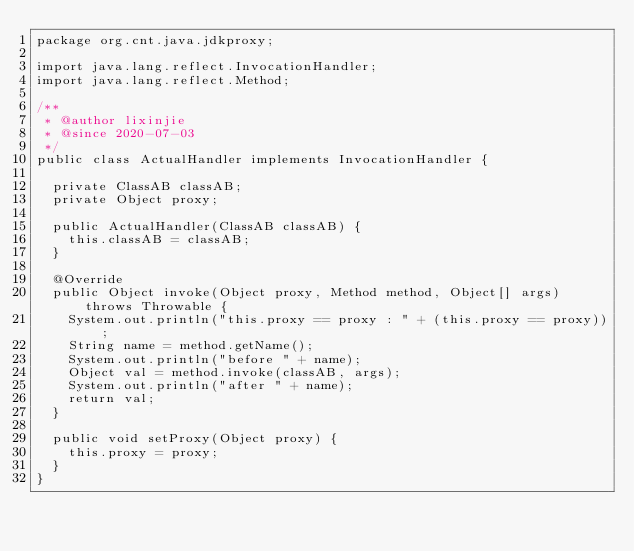<code> <loc_0><loc_0><loc_500><loc_500><_Java_>package org.cnt.java.jdkproxy;

import java.lang.reflect.InvocationHandler;
import java.lang.reflect.Method;

/**
 * @author lixinjie
 * @since 2020-07-03
 */
public class ActualHandler implements InvocationHandler {

	private ClassAB classAB;
	private Object proxy;
	
	public ActualHandler(ClassAB classAB) {
		this.classAB = classAB;
	}
	
	@Override
	public Object invoke(Object proxy, Method method, Object[] args) throws Throwable {
		System.out.println("this.proxy == proxy : " + (this.proxy == proxy));
		String name = method.getName();
		System.out.println("before " + name);
		Object val = method.invoke(classAB, args);
		System.out.println("after " + name);
		return val;
	}

	public void setProxy(Object proxy) {
		this.proxy = proxy;
	}
}
</code> 